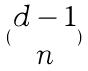Convert formula to latex. <formula><loc_0><loc_0><loc_500><loc_500>( \begin{matrix} d - 1 \\ n \end{matrix} )</formula> 